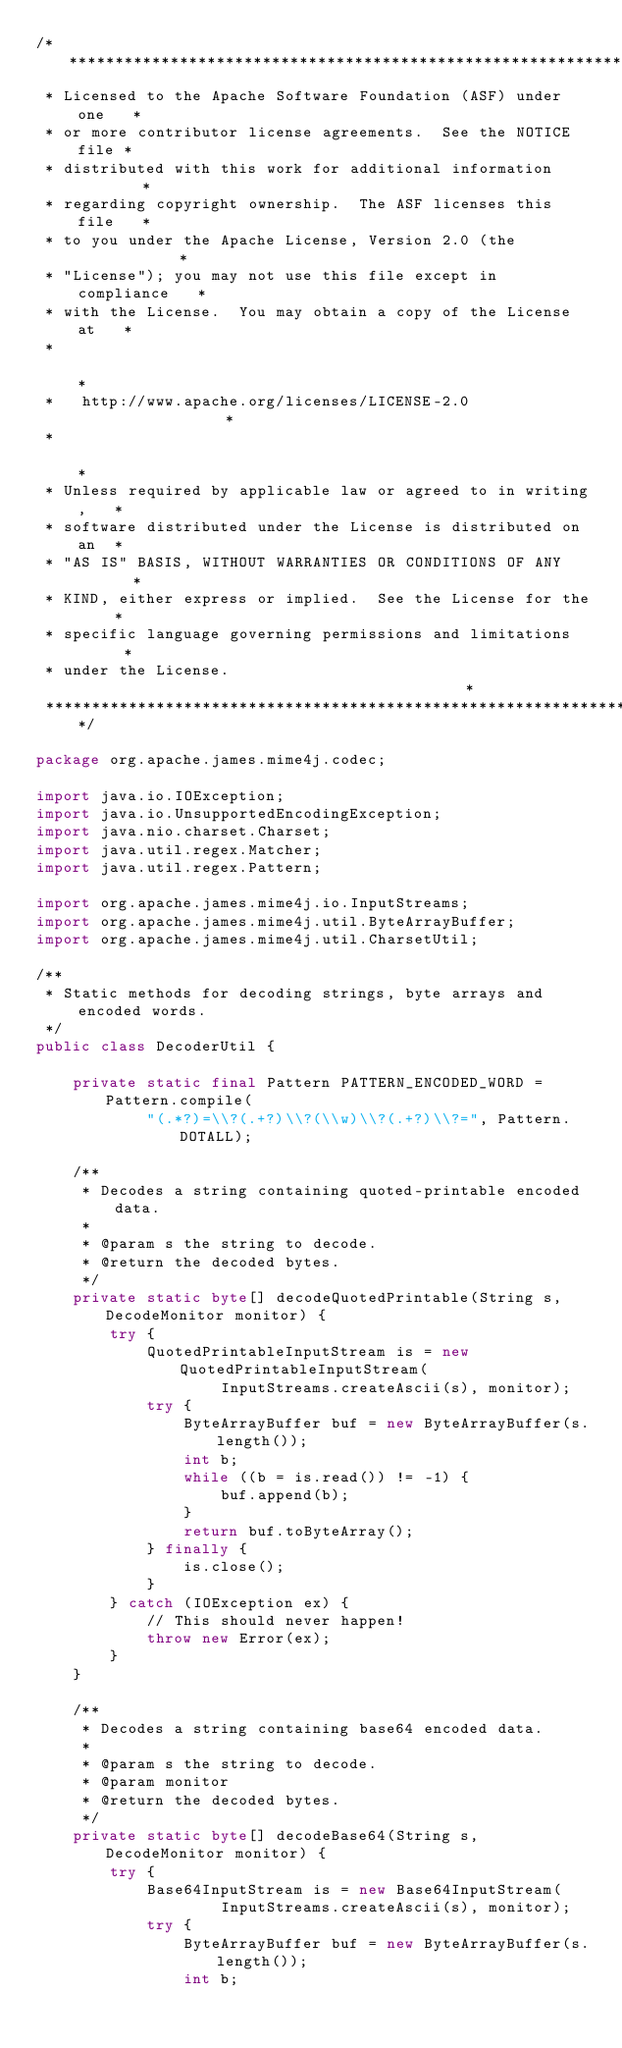Convert code to text. <code><loc_0><loc_0><loc_500><loc_500><_Java_>/****************************************************************
 * Licensed to the Apache Software Foundation (ASF) under one   *
 * or more contributor license agreements.  See the NOTICE file *
 * distributed with this work for additional information        *
 * regarding copyright ownership.  The ASF licenses this file   *
 * to you under the Apache License, Version 2.0 (the            *
 * "License"); you may not use this file except in compliance   *
 * with the License.  You may obtain a copy of the License at   *
 *                                                              *
 *   http://www.apache.org/licenses/LICENSE-2.0                 *
 *                                                              *
 * Unless required by applicable law or agreed to in writing,   *
 * software distributed under the License is distributed on an  *
 * "AS IS" BASIS, WITHOUT WARRANTIES OR CONDITIONS OF ANY       *
 * KIND, either express or implied.  See the License for the    *
 * specific language governing permissions and limitations      *
 * under the License.                                           *
 ****************************************************************/

package org.apache.james.mime4j.codec;

import java.io.IOException;
import java.io.UnsupportedEncodingException;
import java.nio.charset.Charset;
import java.util.regex.Matcher;
import java.util.regex.Pattern;

import org.apache.james.mime4j.io.InputStreams;
import org.apache.james.mime4j.util.ByteArrayBuffer;
import org.apache.james.mime4j.util.CharsetUtil;

/**
 * Static methods for decoding strings, byte arrays and encoded words.
 */
public class DecoderUtil {

    private static final Pattern PATTERN_ENCODED_WORD = Pattern.compile(
            "(.*?)=\\?(.+?)\\?(\\w)\\?(.+?)\\?=", Pattern.DOTALL);

    /**
     * Decodes a string containing quoted-printable encoded data.
     *
     * @param s the string to decode.
     * @return the decoded bytes.
     */
    private static byte[] decodeQuotedPrintable(String s, DecodeMonitor monitor) {
        try {
            QuotedPrintableInputStream is = new QuotedPrintableInputStream(
                    InputStreams.createAscii(s), monitor);
            try {
                ByteArrayBuffer buf = new ByteArrayBuffer(s.length());
                int b;
                while ((b = is.read()) != -1) {
                    buf.append(b);
                }
                return buf.toByteArray();
            } finally {
                is.close();
            }
        } catch (IOException ex) {
            // This should never happen!
            throw new Error(ex);
        }
    }

    /**
     * Decodes a string containing base64 encoded data.
     *
     * @param s the string to decode.
     * @param monitor
     * @return the decoded bytes.
     */
    private static byte[] decodeBase64(String s, DecodeMonitor monitor) {
        try {
            Base64InputStream is = new Base64InputStream(
                    InputStreams.createAscii(s), monitor);
            try {
                ByteArrayBuffer buf = new ByteArrayBuffer(s.length());
                int b;</code> 